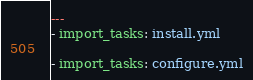<code> <loc_0><loc_0><loc_500><loc_500><_YAML_>---
- import_tasks: install.yml

- import_tasks: configure.yml
</code> 